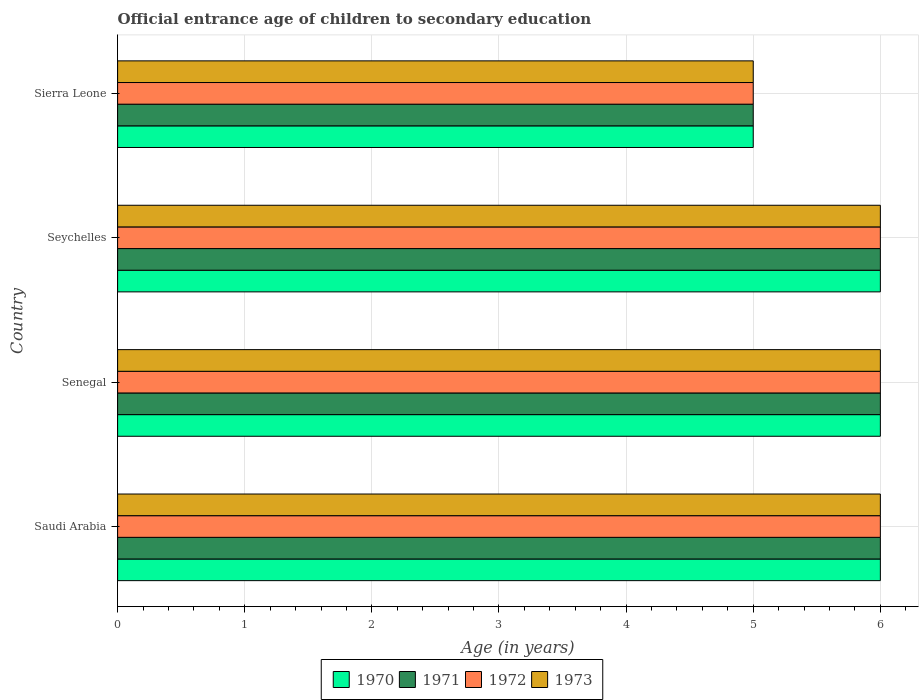How many bars are there on the 3rd tick from the top?
Offer a terse response. 4. How many bars are there on the 4th tick from the bottom?
Provide a short and direct response. 4. What is the label of the 2nd group of bars from the top?
Make the answer very short. Seychelles. Across all countries, what is the minimum secondary school starting age of children in 1971?
Provide a succinct answer. 5. In which country was the secondary school starting age of children in 1971 maximum?
Offer a terse response. Saudi Arabia. In which country was the secondary school starting age of children in 1970 minimum?
Provide a succinct answer. Sierra Leone. What is the difference between the secondary school starting age of children in 1973 in Saudi Arabia and that in Sierra Leone?
Keep it short and to the point. 1. What is the average secondary school starting age of children in 1973 per country?
Give a very brief answer. 5.75. What is the difference between the secondary school starting age of children in 1970 and secondary school starting age of children in 1972 in Saudi Arabia?
Your response must be concise. 0. What is the ratio of the secondary school starting age of children in 1970 in Seychelles to that in Sierra Leone?
Offer a very short reply. 1.2. What is the difference between the highest and the second highest secondary school starting age of children in 1972?
Your answer should be very brief. 0. What is the difference between the highest and the lowest secondary school starting age of children in 1970?
Provide a short and direct response. 1. In how many countries, is the secondary school starting age of children in 1973 greater than the average secondary school starting age of children in 1973 taken over all countries?
Give a very brief answer. 3. Is the sum of the secondary school starting age of children in 1972 in Saudi Arabia and Seychelles greater than the maximum secondary school starting age of children in 1971 across all countries?
Keep it short and to the point. Yes. Is it the case that in every country, the sum of the secondary school starting age of children in 1972 and secondary school starting age of children in 1973 is greater than the sum of secondary school starting age of children in 1971 and secondary school starting age of children in 1970?
Provide a short and direct response. No. What does the 3rd bar from the bottom in Seychelles represents?
Ensure brevity in your answer.  1972. Is it the case that in every country, the sum of the secondary school starting age of children in 1971 and secondary school starting age of children in 1973 is greater than the secondary school starting age of children in 1972?
Give a very brief answer. Yes. How many bars are there?
Offer a very short reply. 16. Are the values on the major ticks of X-axis written in scientific E-notation?
Provide a short and direct response. No. Does the graph contain grids?
Give a very brief answer. Yes. Where does the legend appear in the graph?
Keep it short and to the point. Bottom center. How many legend labels are there?
Make the answer very short. 4. How are the legend labels stacked?
Your answer should be compact. Horizontal. What is the title of the graph?
Provide a short and direct response. Official entrance age of children to secondary education. Does "1982" appear as one of the legend labels in the graph?
Keep it short and to the point. No. What is the label or title of the X-axis?
Offer a very short reply. Age (in years). What is the label or title of the Y-axis?
Give a very brief answer. Country. What is the Age (in years) in 1970 in Senegal?
Provide a succinct answer. 6. What is the Age (in years) of 1972 in Senegal?
Provide a short and direct response. 6. What is the Age (in years) of 1970 in Seychelles?
Your response must be concise. 6. What is the Age (in years) in 1971 in Seychelles?
Your response must be concise. 6. What is the Age (in years) in 1972 in Seychelles?
Make the answer very short. 6. What is the Age (in years) of 1973 in Seychelles?
Offer a very short reply. 6. What is the Age (in years) in 1971 in Sierra Leone?
Ensure brevity in your answer.  5. What is the Age (in years) in 1972 in Sierra Leone?
Offer a very short reply. 5. Across all countries, what is the maximum Age (in years) of 1970?
Provide a short and direct response. 6. Across all countries, what is the maximum Age (in years) of 1971?
Provide a succinct answer. 6. Across all countries, what is the minimum Age (in years) in 1971?
Make the answer very short. 5. Across all countries, what is the minimum Age (in years) of 1972?
Make the answer very short. 5. Across all countries, what is the minimum Age (in years) in 1973?
Provide a succinct answer. 5. What is the total Age (in years) in 1970 in the graph?
Give a very brief answer. 23. What is the total Age (in years) of 1971 in the graph?
Your response must be concise. 23. What is the total Age (in years) of 1972 in the graph?
Your answer should be compact. 23. What is the difference between the Age (in years) in 1970 in Saudi Arabia and that in Senegal?
Ensure brevity in your answer.  0. What is the difference between the Age (in years) of 1970 in Saudi Arabia and that in Seychelles?
Provide a short and direct response. 0. What is the difference between the Age (in years) of 1970 in Saudi Arabia and that in Sierra Leone?
Make the answer very short. 1. What is the difference between the Age (in years) of 1972 in Saudi Arabia and that in Sierra Leone?
Offer a very short reply. 1. What is the difference between the Age (in years) in 1971 in Senegal and that in Seychelles?
Make the answer very short. 0. What is the difference between the Age (in years) in 1973 in Senegal and that in Sierra Leone?
Your response must be concise. 1. What is the difference between the Age (in years) of 1970 in Seychelles and that in Sierra Leone?
Keep it short and to the point. 1. What is the difference between the Age (in years) in 1971 in Seychelles and that in Sierra Leone?
Make the answer very short. 1. What is the difference between the Age (in years) of 1973 in Seychelles and that in Sierra Leone?
Offer a terse response. 1. What is the difference between the Age (in years) of 1970 in Saudi Arabia and the Age (in years) of 1971 in Senegal?
Ensure brevity in your answer.  0. What is the difference between the Age (in years) in 1970 in Saudi Arabia and the Age (in years) in 1973 in Senegal?
Offer a terse response. 0. What is the difference between the Age (in years) in 1970 in Saudi Arabia and the Age (in years) in 1973 in Seychelles?
Your answer should be very brief. 0. What is the difference between the Age (in years) of 1971 in Saudi Arabia and the Age (in years) of 1973 in Seychelles?
Ensure brevity in your answer.  0. What is the difference between the Age (in years) of 1972 in Saudi Arabia and the Age (in years) of 1973 in Seychelles?
Your answer should be very brief. 0. What is the difference between the Age (in years) in 1970 in Saudi Arabia and the Age (in years) in 1971 in Sierra Leone?
Your answer should be compact. 1. What is the difference between the Age (in years) of 1972 in Saudi Arabia and the Age (in years) of 1973 in Sierra Leone?
Keep it short and to the point. 1. What is the difference between the Age (in years) of 1970 in Senegal and the Age (in years) of 1973 in Seychelles?
Your answer should be very brief. 0. What is the difference between the Age (in years) in 1972 in Senegal and the Age (in years) in 1973 in Seychelles?
Make the answer very short. 0. What is the difference between the Age (in years) in 1970 in Senegal and the Age (in years) in 1971 in Sierra Leone?
Your answer should be compact. 1. What is the difference between the Age (in years) in 1971 in Senegal and the Age (in years) in 1972 in Sierra Leone?
Your answer should be very brief. 1. What is the difference between the Age (in years) of 1972 in Senegal and the Age (in years) of 1973 in Sierra Leone?
Ensure brevity in your answer.  1. What is the difference between the Age (in years) of 1971 in Seychelles and the Age (in years) of 1972 in Sierra Leone?
Your response must be concise. 1. What is the difference between the Age (in years) of 1971 in Seychelles and the Age (in years) of 1973 in Sierra Leone?
Keep it short and to the point. 1. What is the difference between the Age (in years) in 1972 in Seychelles and the Age (in years) in 1973 in Sierra Leone?
Provide a short and direct response. 1. What is the average Age (in years) in 1970 per country?
Your answer should be very brief. 5.75. What is the average Age (in years) in 1971 per country?
Keep it short and to the point. 5.75. What is the average Age (in years) of 1972 per country?
Your answer should be compact. 5.75. What is the average Age (in years) in 1973 per country?
Your answer should be compact. 5.75. What is the difference between the Age (in years) of 1970 and Age (in years) of 1972 in Saudi Arabia?
Your answer should be very brief. 0. What is the difference between the Age (in years) of 1970 and Age (in years) of 1973 in Saudi Arabia?
Ensure brevity in your answer.  0. What is the difference between the Age (in years) of 1971 and Age (in years) of 1973 in Saudi Arabia?
Offer a very short reply. 0. What is the difference between the Age (in years) in 1972 and Age (in years) in 1973 in Saudi Arabia?
Your answer should be very brief. 0. What is the difference between the Age (in years) of 1970 and Age (in years) of 1971 in Senegal?
Provide a succinct answer. 0. What is the difference between the Age (in years) in 1970 and Age (in years) in 1972 in Senegal?
Your answer should be compact. 0. What is the difference between the Age (in years) in 1971 and Age (in years) in 1972 in Senegal?
Your response must be concise. 0. What is the difference between the Age (in years) in 1971 and Age (in years) in 1973 in Senegal?
Your answer should be very brief. 0. What is the difference between the Age (in years) in 1972 and Age (in years) in 1973 in Senegal?
Provide a succinct answer. 0. What is the difference between the Age (in years) of 1970 and Age (in years) of 1971 in Seychelles?
Make the answer very short. 0. What is the difference between the Age (in years) in 1971 and Age (in years) in 1972 in Seychelles?
Your answer should be compact. 0. What is the difference between the Age (in years) of 1972 and Age (in years) of 1973 in Seychelles?
Keep it short and to the point. 0. What is the difference between the Age (in years) in 1970 and Age (in years) in 1972 in Sierra Leone?
Your answer should be very brief. 0. What is the difference between the Age (in years) of 1971 and Age (in years) of 1972 in Sierra Leone?
Your answer should be compact. 0. What is the difference between the Age (in years) of 1971 and Age (in years) of 1973 in Sierra Leone?
Your response must be concise. 0. What is the difference between the Age (in years) in 1972 and Age (in years) in 1973 in Sierra Leone?
Offer a terse response. 0. What is the ratio of the Age (in years) of 1971 in Saudi Arabia to that in Senegal?
Your answer should be compact. 1. What is the ratio of the Age (in years) of 1973 in Saudi Arabia to that in Senegal?
Give a very brief answer. 1. What is the ratio of the Age (in years) of 1970 in Saudi Arabia to that in Seychelles?
Offer a terse response. 1. What is the ratio of the Age (in years) in 1971 in Saudi Arabia to that in Seychelles?
Your answer should be very brief. 1. What is the ratio of the Age (in years) in 1972 in Saudi Arabia to that in Seychelles?
Ensure brevity in your answer.  1. What is the ratio of the Age (in years) in 1973 in Saudi Arabia to that in Seychelles?
Offer a very short reply. 1. What is the ratio of the Age (in years) of 1970 in Senegal to that in Sierra Leone?
Offer a very short reply. 1.2. What is the ratio of the Age (in years) of 1971 in Senegal to that in Sierra Leone?
Provide a succinct answer. 1.2. What is the ratio of the Age (in years) in 1973 in Senegal to that in Sierra Leone?
Offer a very short reply. 1.2. What is the ratio of the Age (in years) in 1970 in Seychelles to that in Sierra Leone?
Provide a succinct answer. 1.2. What is the ratio of the Age (in years) in 1972 in Seychelles to that in Sierra Leone?
Ensure brevity in your answer.  1.2. What is the ratio of the Age (in years) of 1973 in Seychelles to that in Sierra Leone?
Make the answer very short. 1.2. What is the difference between the highest and the second highest Age (in years) of 1970?
Your answer should be compact. 0. What is the difference between the highest and the second highest Age (in years) of 1973?
Your answer should be very brief. 0. What is the difference between the highest and the lowest Age (in years) in 1970?
Offer a terse response. 1. What is the difference between the highest and the lowest Age (in years) of 1971?
Provide a short and direct response. 1. What is the difference between the highest and the lowest Age (in years) in 1973?
Give a very brief answer. 1. 